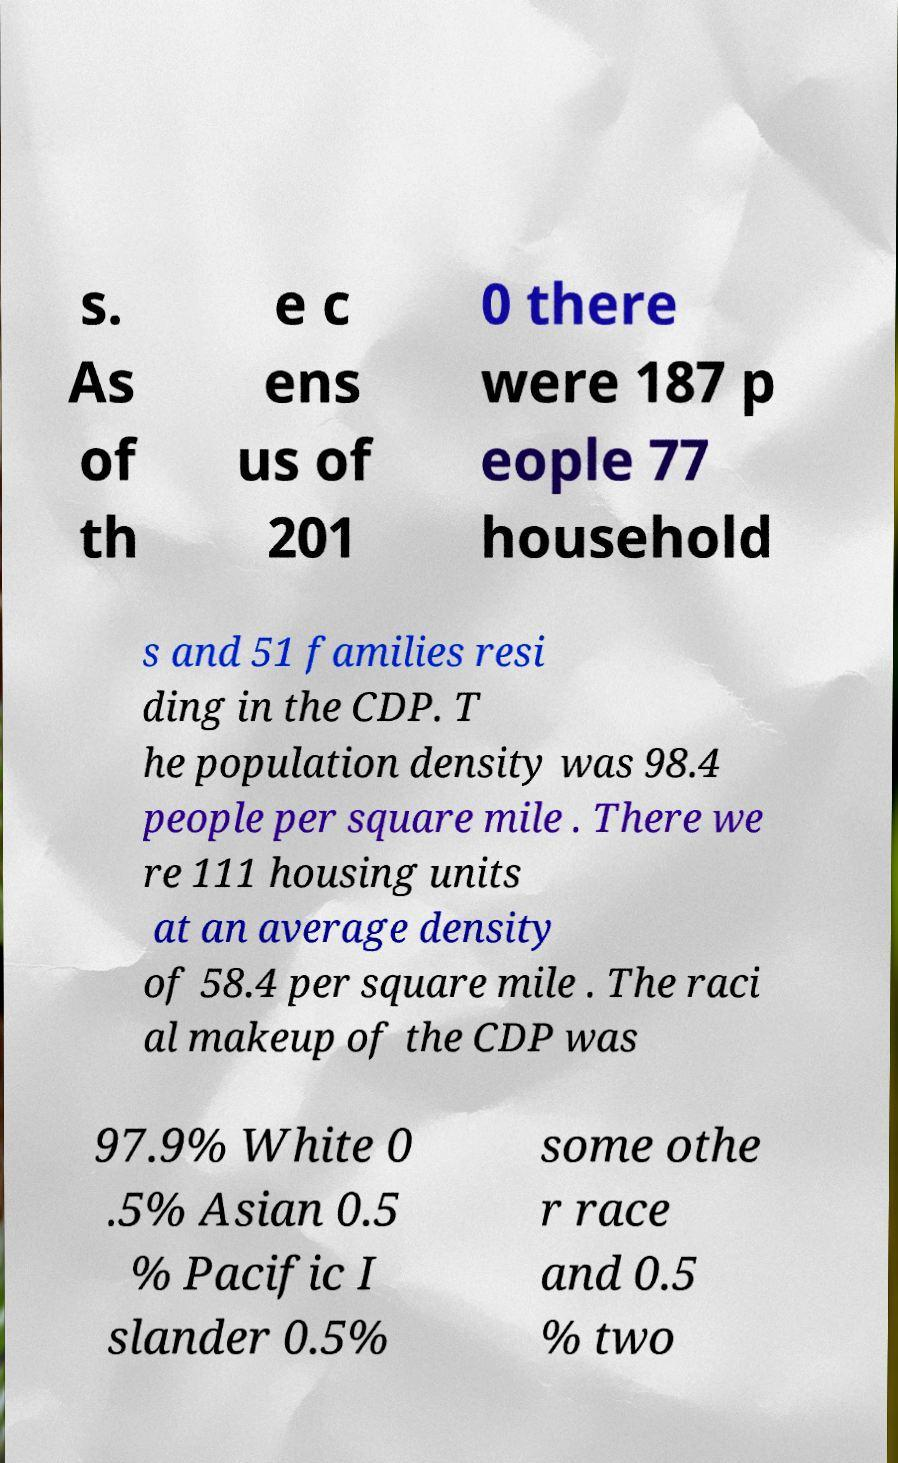Could you extract and type out the text from this image? s. As of th e c ens us of 201 0 there were 187 p eople 77 household s and 51 families resi ding in the CDP. T he population density was 98.4 people per square mile . There we re 111 housing units at an average density of 58.4 per square mile . The raci al makeup of the CDP was 97.9% White 0 .5% Asian 0.5 % Pacific I slander 0.5% some othe r race and 0.5 % two 